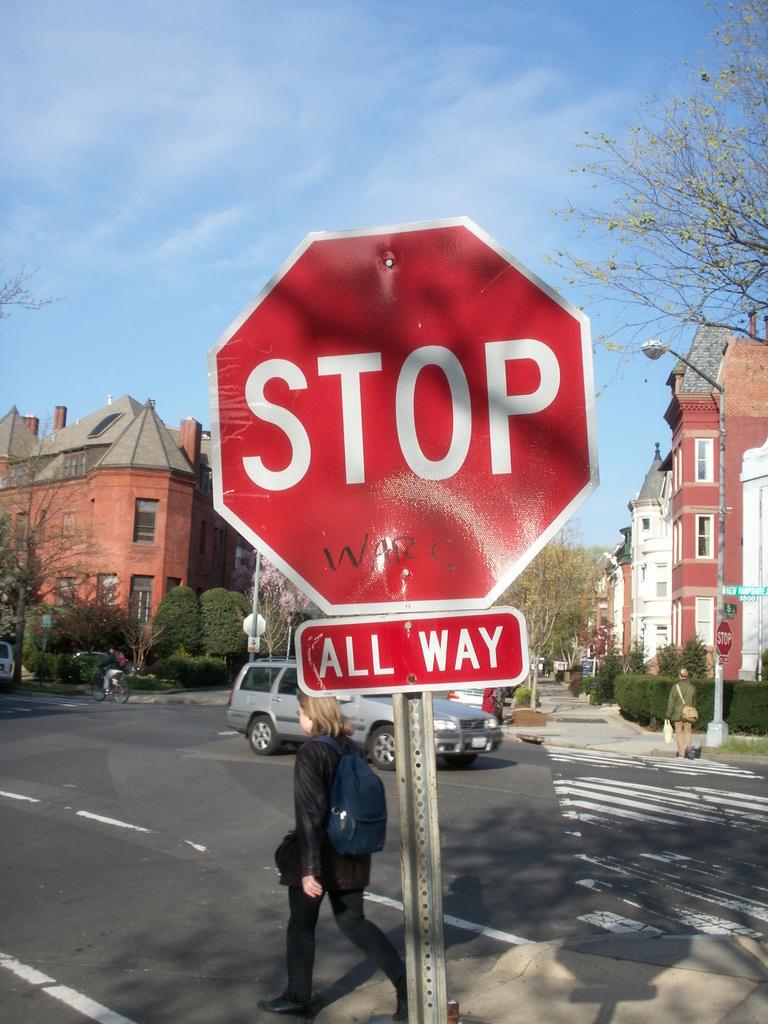What does the sign say?
Provide a succinct answer. Stop all way. This is a what way stop?
Make the answer very short. All way. 